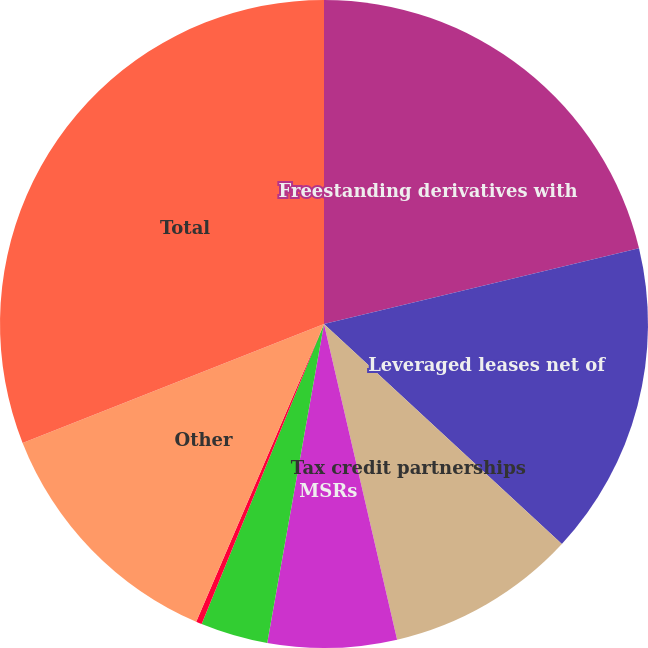<chart> <loc_0><loc_0><loc_500><loc_500><pie_chart><fcel>Freestanding derivatives with<fcel>Leveraged leases net of<fcel>Tax credit partnerships<fcel>MSRs<fcel>Funds withheld<fcel>Joint venture investments<fcel>Other<fcel>Total<nl><fcel>21.25%<fcel>15.64%<fcel>9.5%<fcel>6.43%<fcel>3.36%<fcel>0.29%<fcel>12.57%<fcel>30.99%<nl></chart> 